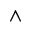<formula> <loc_0><loc_0><loc_500><loc_500>\wedge</formula> 